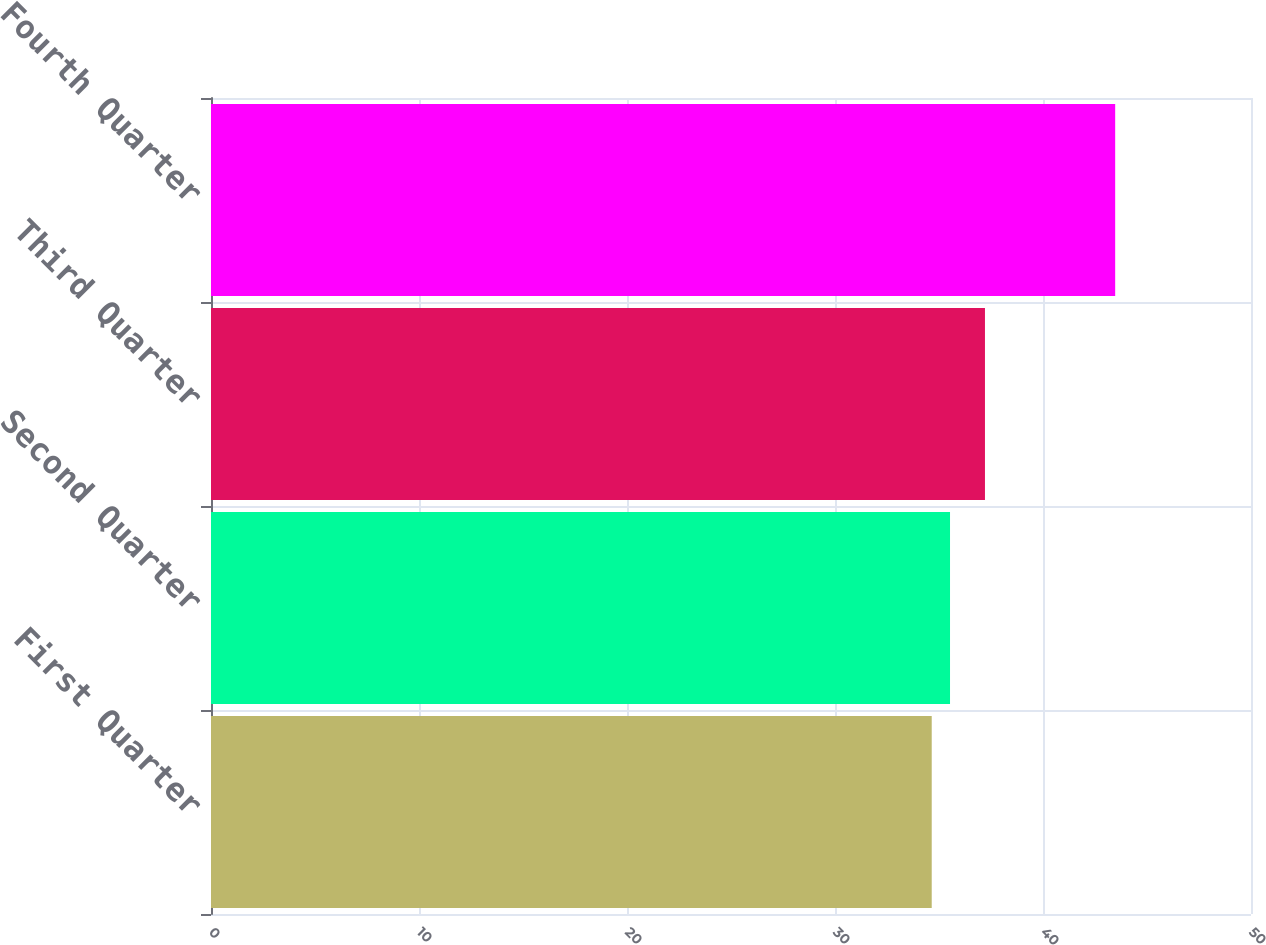Convert chart. <chart><loc_0><loc_0><loc_500><loc_500><bar_chart><fcel>First Quarter<fcel>Second Quarter<fcel>Third Quarter<fcel>Fourth Quarter<nl><fcel>34.65<fcel>35.53<fcel>37.21<fcel>43.47<nl></chart> 